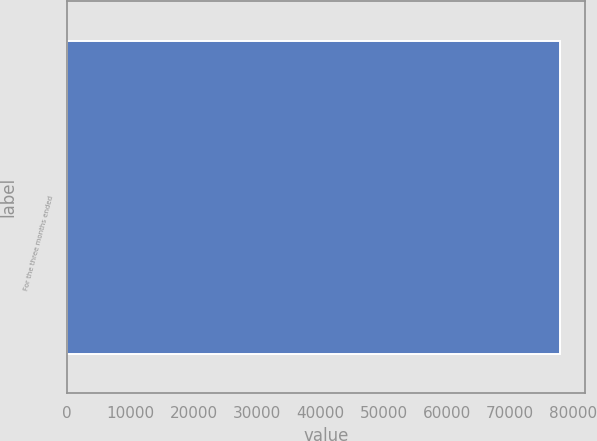<chart> <loc_0><loc_0><loc_500><loc_500><bar_chart><fcel>For the three months ended<nl><fcel>77910<nl></chart> 